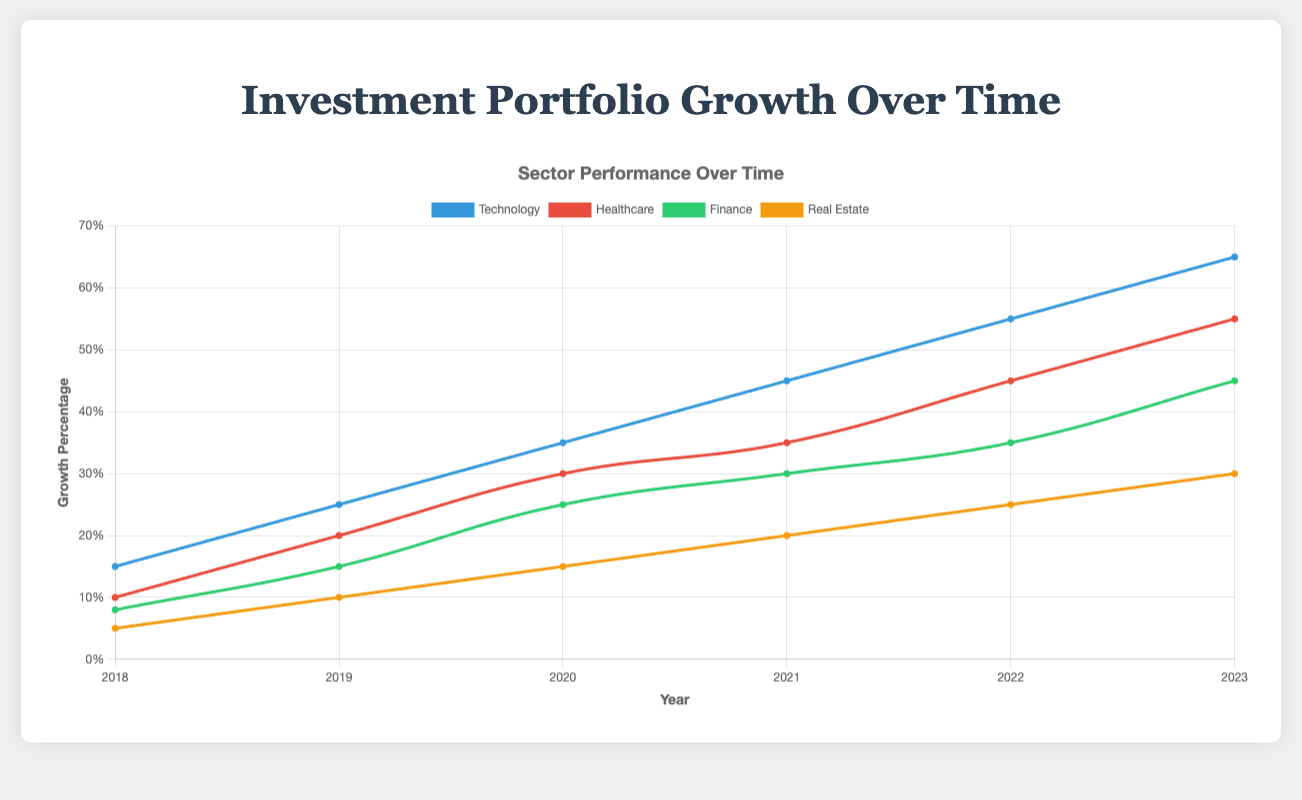What sector had the highest growth percentage in 2023? The chart indicates growth percentages over the years, and looking at 2023, the Technology sector had the highest growth percentage.
Answer: Technology Which sector consistently had the lowest growth percentage from 2018 to 2023? By observing each year's data, the Real Estate sector consistently had the lowest growth percentages compared to the other sectors from 2018 to 2023.
Answer: Real Estate By how much did the growth percentage in the Technology sector increase from 2018 to 2023? The growth percentage for Technology in 2018 was 15%, and in 2023 it was 65%. The increase is 65% - 15% = 50%.
Answer: 50% Compare the growth percentage of the Healthcare sector in 2019 to the Finance sector in 2021. Which is higher and by how much? The Healthcare sector in 2019 had a growth percentage of 20%, while the Finance sector in 2021 had a growth percentage of 30%. The Finance sector in 2021 is higher by 30% - 20% = 10%.
Answer: Finance by 10% What is the average growth percentage of the Real Estate sector between 2018 and 2023? The growth percentages for Real Estate from 2018 to 2023 are 5%, 10%, 15%, 20%, 25%, and 30%. The average is (5 + 10 + 15 + 20 + 25 + 30) / 6 = 17.5%.
Answer: 17.5% In which year did the Finance sector have the highest growth percentage? By examining the Finance sector's line in the chart, the highest growth percentage was in 2023 at 45%.
Answer: 2023 Describe the trend in the Healthcare sector's growth percentage from 2018 to 2023. The Healthcare sector shows a steady increase in growth percentage, starting from 10% in 2018 and reaching 55% in 2023.
Answer: Steady increase Which sector had the smallest growth percentage difference between 2022 and 2023? The Real Estate sector had the smallest difference between 2022 and 2023, with percentages of 25% and 30%, resulting in a difference of 30% - 25% = 5%.
Answer: Real Estate From 2018 to 2023, which sector had the most significant increase in growth percentage? Observing all sectors' lines, the Technology sector had the most significant increase in growth percentage from 15% in 2018 to 65% in 2023, which is an increase of 65% - 15% = 50%.
Answer: Technology In 2021, which two sectors had the same growth trend, and what was the percentage difference between their growths? In 2021, the Technology and Finance sectors both showed a consistent positive growth trend. The Technology sector had a growth percentage of 45%, and the Finance sector's was 30%, resulting in a difference of 45% - 30% = 15%.
Answer: Technology and Finance, 15% 